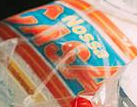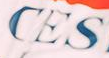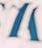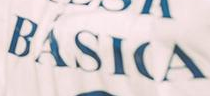What words can you see in these images in sequence, separated by a semicolon? CASA; CES; #; BÁSICA 